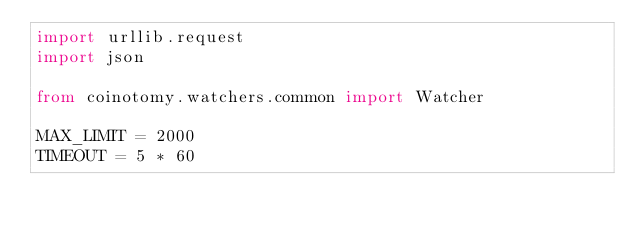Convert code to text. <code><loc_0><loc_0><loc_500><loc_500><_Python_>import urllib.request
import json

from coinotomy.watchers.common import Watcher

MAX_LIMIT = 2000
TIMEOUT = 5 * 60
</code> 